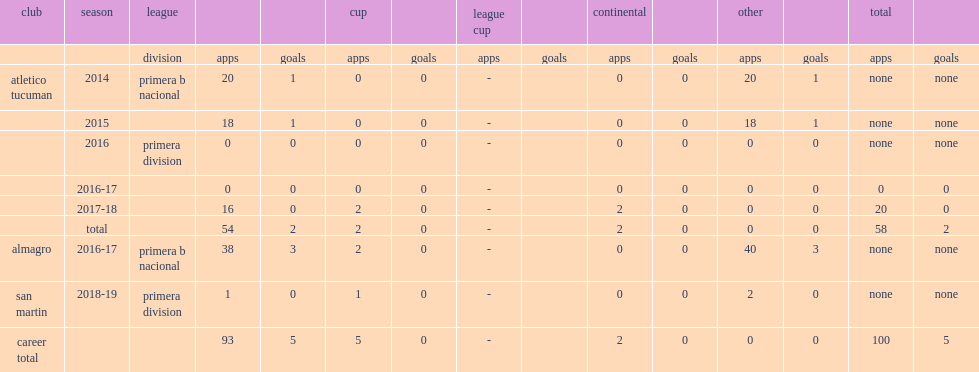Which club did grahl play for in 2014? Atletico tucuman. 